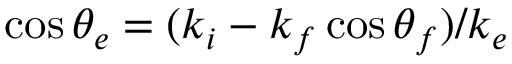Convert formula to latex. <formula><loc_0><loc_0><loc_500><loc_500>\cos \theta _ { e } = { ( k _ { i } - k _ { f } \cos \theta _ { f } ) } / { k _ { e } }</formula> 